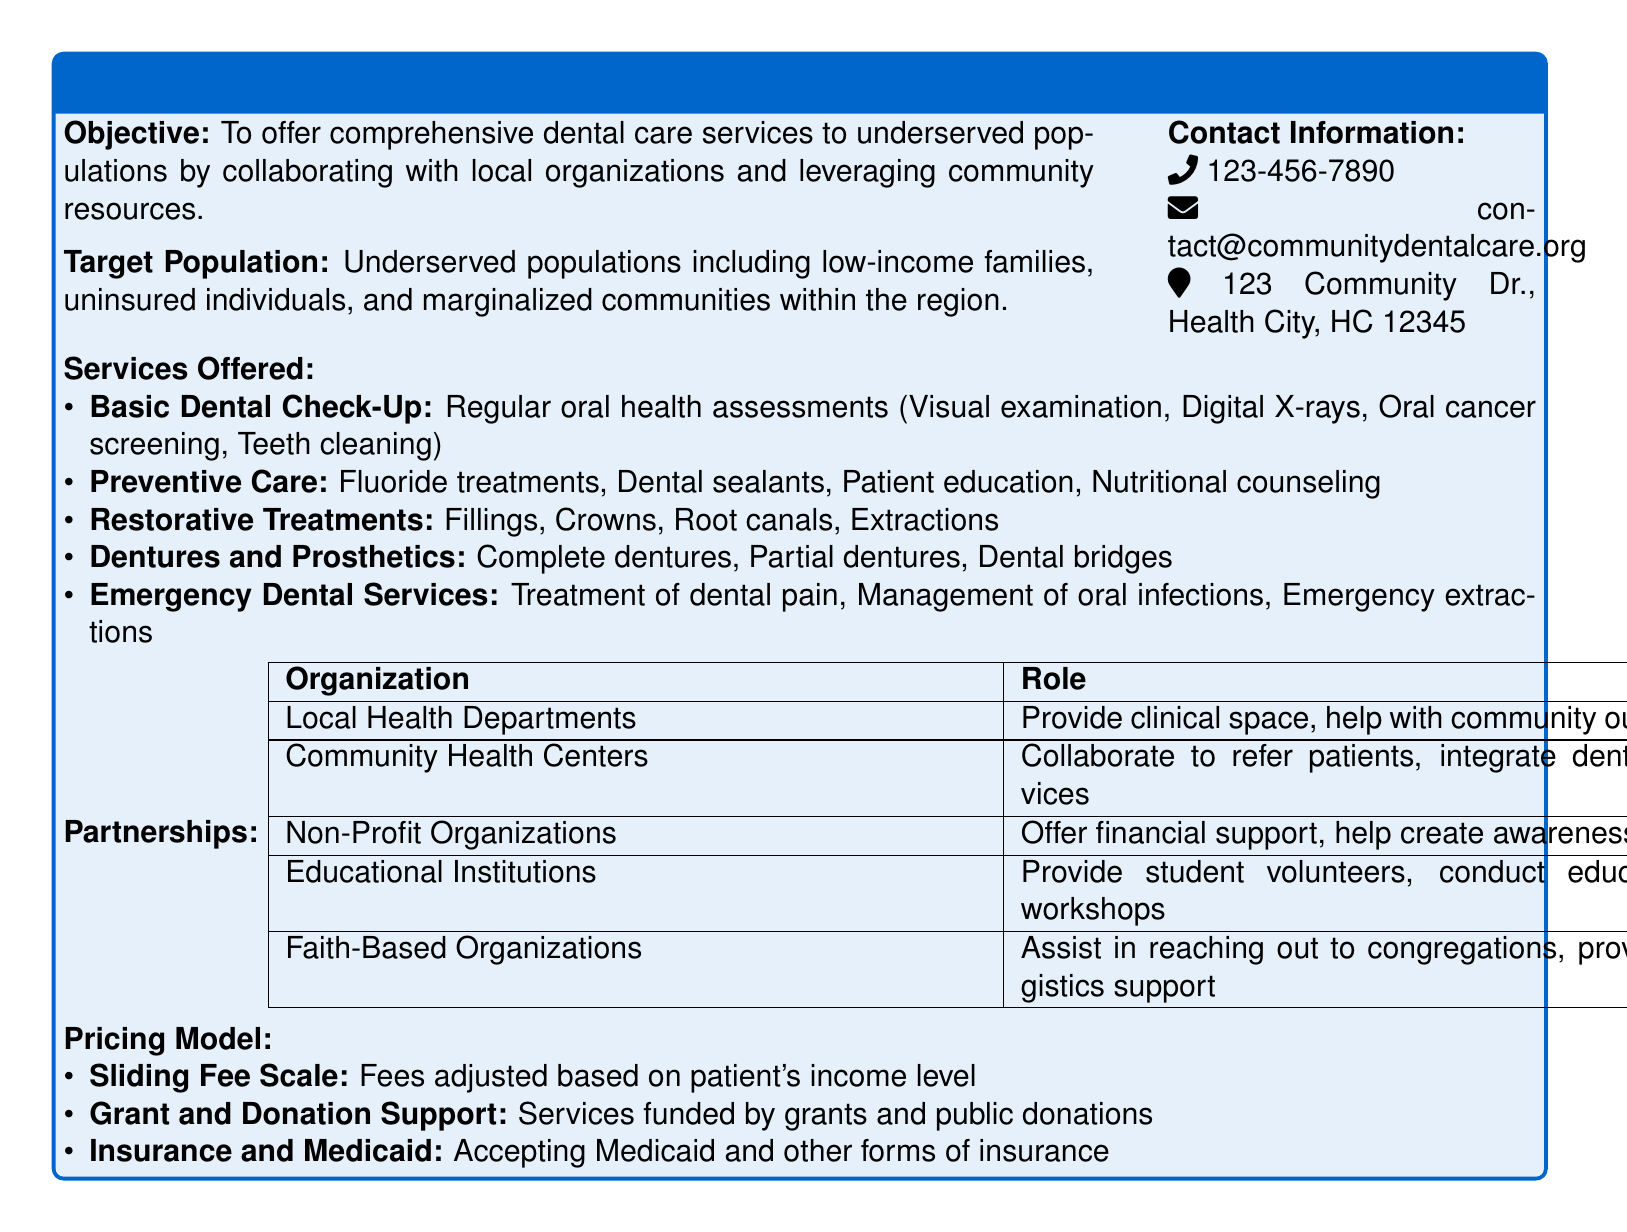what is the objective of the dental service package? The objective is to offer comprehensive dental care services to underserved populations by collaborating with local organizations and leveraging community resources.
Answer: comprehensive dental care services for underserved populations who is the target population for this service? The target population includes low-income families, uninsured individuals, and marginalized communities within the region.
Answer: low-income families, uninsured individuals, and marginalized communities what type of emergency dental services are offered? The document lists treatment of dental pain, management of oral infections, and emergency extractions as emergency dental services.
Answer: treatment of dental pain, management of oral infections, emergency extractions which type of organizations help with community outreach? Local Health Departments assist with clinical space and community outreach.
Answer: Local Health Departments what pricing model is utilized for the dental services? The pricing model includes a sliding fee scale, grant and donation support, and acceptance of Medicaid and other insurance forms.
Answer: sliding fee scale, grant and donation support, insurance acceptance how can one contact the dental service? The contact information includes a phone number, an email address, and a physical address.
Answer: 123-456-7890, contact@communitydentalcare.org, 123 Community Dr., Health City, HC 12345 what are the restorative treatments provided? The restorative treatments include fillings, crowns, root canals, and extractions.
Answer: fillings, crowns, root canals, extractions which organizations provide student volunteers according to the document? Educational Institutions are mentioned as providing student volunteers.
Answer: Educational Institutions what are the components of preventive care listed in the document? The components of preventive care listed include fluoride treatments, dental sealants, patient education, and nutritional counseling.
Answer: fluoride treatments, dental sealants, patient education, nutritional counseling 